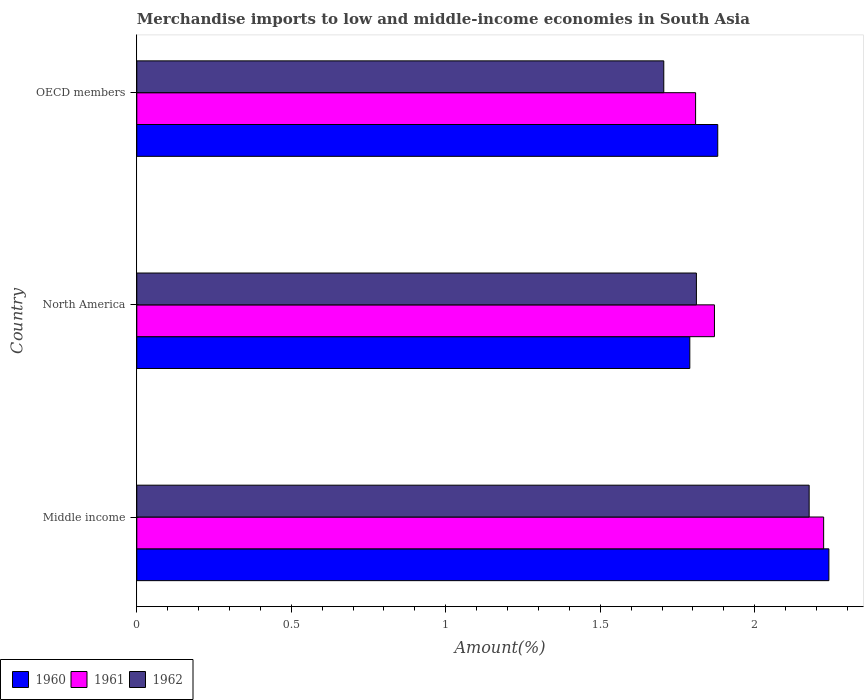How many different coloured bars are there?
Your answer should be compact. 3. How many groups of bars are there?
Your answer should be very brief. 3. Are the number of bars on each tick of the Y-axis equal?
Provide a short and direct response. Yes. In how many cases, is the number of bars for a given country not equal to the number of legend labels?
Ensure brevity in your answer.  0. What is the percentage of amount earned from merchandise imports in 1960 in OECD members?
Offer a terse response. 1.88. Across all countries, what is the maximum percentage of amount earned from merchandise imports in 1961?
Your answer should be very brief. 2.22. Across all countries, what is the minimum percentage of amount earned from merchandise imports in 1961?
Your answer should be compact. 1.81. What is the total percentage of amount earned from merchandise imports in 1962 in the graph?
Make the answer very short. 5.69. What is the difference between the percentage of amount earned from merchandise imports in 1960 in Middle income and that in North America?
Provide a succinct answer. 0.45. What is the difference between the percentage of amount earned from merchandise imports in 1961 in Middle income and the percentage of amount earned from merchandise imports in 1960 in OECD members?
Your response must be concise. 0.34. What is the average percentage of amount earned from merchandise imports in 1961 per country?
Provide a succinct answer. 1.97. What is the difference between the percentage of amount earned from merchandise imports in 1962 and percentage of amount earned from merchandise imports in 1961 in OECD members?
Ensure brevity in your answer.  -0.1. What is the ratio of the percentage of amount earned from merchandise imports in 1961 in North America to that in OECD members?
Your answer should be compact. 1.03. Is the difference between the percentage of amount earned from merchandise imports in 1962 in North America and OECD members greater than the difference between the percentage of amount earned from merchandise imports in 1961 in North America and OECD members?
Your answer should be very brief. Yes. What is the difference between the highest and the second highest percentage of amount earned from merchandise imports in 1962?
Your answer should be compact. 0.36. What is the difference between the highest and the lowest percentage of amount earned from merchandise imports in 1962?
Give a very brief answer. 0.47. In how many countries, is the percentage of amount earned from merchandise imports in 1961 greater than the average percentage of amount earned from merchandise imports in 1961 taken over all countries?
Provide a succinct answer. 1. Is the sum of the percentage of amount earned from merchandise imports in 1962 in Middle income and North America greater than the maximum percentage of amount earned from merchandise imports in 1961 across all countries?
Provide a short and direct response. Yes. Is it the case that in every country, the sum of the percentage of amount earned from merchandise imports in 1961 and percentage of amount earned from merchandise imports in 1960 is greater than the percentage of amount earned from merchandise imports in 1962?
Your answer should be compact. Yes. How many bars are there?
Offer a very short reply. 9. Are all the bars in the graph horizontal?
Offer a very short reply. Yes. What is the difference between two consecutive major ticks on the X-axis?
Your response must be concise. 0.5. Does the graph contain any zero values?
Your answer should be very brief. No. What is the title of the graph?
Your response must be concise. Merchandise imports to low and middle-income economies in South Asia. Does "2001" appear as one of the legend labels in the graph?
Offer a terse response. No. What is the label or title of the X-axis?
Keep it short and to the point. Amount(%). What is the label or title of the Y-axis?
Ensure brevity in your answer.  Country. What is the Amount(%) in 1960 in Middle income?
Make the answer very short. 2.24. What is the Amount(%) of 1961 in Middle income?
Your answer should be compact. 2.22. What is the Amount(%) in 1962 in Middle income?
Make the answer very short. 2.18. What is the Amount(%) in 1960 in North America?
Offer a very short reply. 1.79. What is the Amount(%) of 1961 in North America?
Give a very brief answer. 1.87. What is the Amount(%) of 1962 in North America?
Ensure brevity in your answer.  1.81. What is the Amount(%) in 1960 in OECD members?
Provide a short and direct response. 1.88. What is the Amount(%) of 1961 in OECD members?
Your response must be concise. 1.81. What is the Amount(%) of 1962 in OECD members?
Provide a short and direct response. 1.71. Across all countries, what is the maximum Amount(%) of 1960?
Ensure brevity in your answer.  2.24. Across all countries, what is the maximum Amount(%) of 1961?
Provide a short and direct response. 2.22. Across all countries, what is the maximum Amount(%) of 1962?
Give a very brief answer. 2.18. Across all countries, what is the minimum Amount(%) of 1960?
Offer a very short reply. 1.79. Across all countries, what is the minimum Amount(%) in 1961?
Your answer should be very brief. 1.81. Across all countries, what is the minimum Amount(%) of 1962?
Offer a very short reply. 1.71. What is the total Amount(%) of 1960 in the graph?
Offer a very short reply. 5.91. What is the total Amount(%) in 1961 in the graph?
Make the answer very short. 5.9. What is the total Amount(%) in 1962 in the graph?
Make the answer very short. 5.69. What is the difference between the Amount(%) in 1960 in Middle income and that in North America?
Offer a very short reply. 0.45. What is the difference between the Amount(%) of 1961 in Middle income and that in North America?
Provide a succinct answer. 0.35. What is the difference between the Amount(%) in 1962 in Middle income and that in North America?
Ensure brevity in your answer.  0.36. What is the difference between the Amount(%) in 1960 in Middle income and that in OECD members?
Ensure brevity in your answer.  0.36. What is the difference between the Amount(%) in 1961 in Middle income and that in OECD members?
Your answer should be very brief. 0.41. What is the difference between the Amount(%) in 1962 in Middle income and that in OECD members?
Ensure brevity in your answer.  0.47. What is the difference between the Amount(%) of 1960 in North America and that in OECD members?
Provide a succinct answer. -0.09. What is the difference between the Amount(%) in 1961 in North America and that in OECD members?
Your answer should be compact. 0.06. What is the difference between the Amount(%) in 1962 in North America and that in OECD members?
Your answer should be very brief. 0.11. What is the difference between the Amount(%) in 1960 in Middle income and the Amount(%) in 1961 in North America?
Provide a succinct answer. 0.37. What is the difference between the Amount(%) of 1960 in Middle income and the Amount(%) of 1962 in North America?
Provide a succinct answer. 0.43. What is the difference between the Amount(%) in 1961 in Middle income and the Amount(%) in 1962 in North America?
Ensure brevity in your answer.  0.41. What is the difference between the Amount(%) in 1960 in Middle income and the Amount(%) in 1961 in OECD members?
Your response must be concise. 0.43. What is the difference between the Amount(%) of 1960 in Middle income and the Amount(%) of 1962 in OECD members?
Keep it short and to the point. 0.53. What is the difference between the Amount(%) of 1961 in Middle income and the Amount(%) of 1962 in OECD members?
Provide a short and direct response. 0.52. What is the difference between the Amount(%) in 1960 in North America and the Amount(%) in 1961 in OECD members?
Ensure brevity in your answer.  -0.02. What is the difference between the Amount(%) in 1960 in North America and the Amount(%) in 1962 in OECD members?
Give a very brief answer. 0.08. What is the difference between the Amount(%) in 1961 in North America and the Amount(%) in 1962 in OECD members?
Provide a short and direct response. 0.16. What is the average Amount(%) of 1960 per country?
Keep it short and to the point. 1.97. What is the average Amount(%) of 1961 per country?
Keep it short and to the point. 1.97. What is the average Amount(%) of 1962 per country?
Your answer should be compact. 1.9. What is the difference between the Amount(%) in 1960 and Amount(%) in 1961 in Middle income?
Keep it short and to the point. 0.02. What is the difference between the Amount(%) in 1960 and Amount(%) in 1962 in Middle income?
Your answer should be compact. 0.06. What is the difference between the Amount(%) of 1961 and Amount(%) of 1962 in Middle income?
Offer a terse response. 0.05. What is the difference between the Amount(%) in 1960 and Amount(%) in 1961 in North America?
Provide a short and direct response. -0.08. What is the difference between the Amount(%) in 1960 and Amount(%) in 1962 in North America?
Provide a succinct answer. -0.02. What is the difference between the Amount(%) of 1961 and Amount(%) of 1962 in North America?
Provide a succinct answer. 0.06. What is the difference between the Amount(%) in 1960 and Amount(%) in 1961 in OECD members?
Offer a terse response. 0.07. What is the difference between the Amount(%) in 1960 and Amount(%) in 1962 in OECD members?
Your response must be concise. 0.17. What is the difference between the Amount(%) of 1961 and Amount(%) of 1962 in OECD members?
Your answer should be compact. 0.1. What is the ratio of the Amount(%) of 1960 in Middle income to that in North America?
Provide a succinct answer. 1.25. What is the ratio of the Amount(%) of 1961 in Middle income to that in North America?
Ensure brevity in your answer.  1.19. What is the ratio of the Amount(%) in 1962 in Middle income to that in North America?
Give a very brief answer. 1.2. What is the ratio of the Amount(%) of 1960 in Middle income to that in OECD members?
Give a very brief answer. 1.19. What is the ratio of the Amount(%) in 1961 in Middle income to that in OECD members?
Your answer should be compact. 1.23. What is the ratio of the Amount(%) of 1962 in Middle income to that in OECD members?
Provide a short and direct response. 1.28. What is the ratio of the Amount(%) in 1960 in North America to that in OECD members?
Your answer should be very brief. 0.95. What is the ratio of the Amount(%) of 1961 in North America to that in OECD members?
Offer a very short reply. 1.03. What is the ratio of the Amount(%) in 1962 in North America to that in OECD members?
Your response must be concise. 1.06. What is the difference between the highest and the second highest Amount(%) of 1960?
Keep it short and to the point. 0.36. What is the difference between the highest and the second highest Amount(%) in 1961?
Offer a terse response. 0.35. What is the difference between the highest and the second highest Amount(%) in 1962?
Your response must be concise. 0.36. What is the difference between the highest and the lowest Amount(%) in 1960?
Your answer should be compact. 0.45. What is the difference between the highest and the lowest Amount(%) in 1961?
Offer a terse response. 0.41. What is the difference between the highest and the lowest Amount(%) in 1962?
Your answer should be compact. 0.47. 